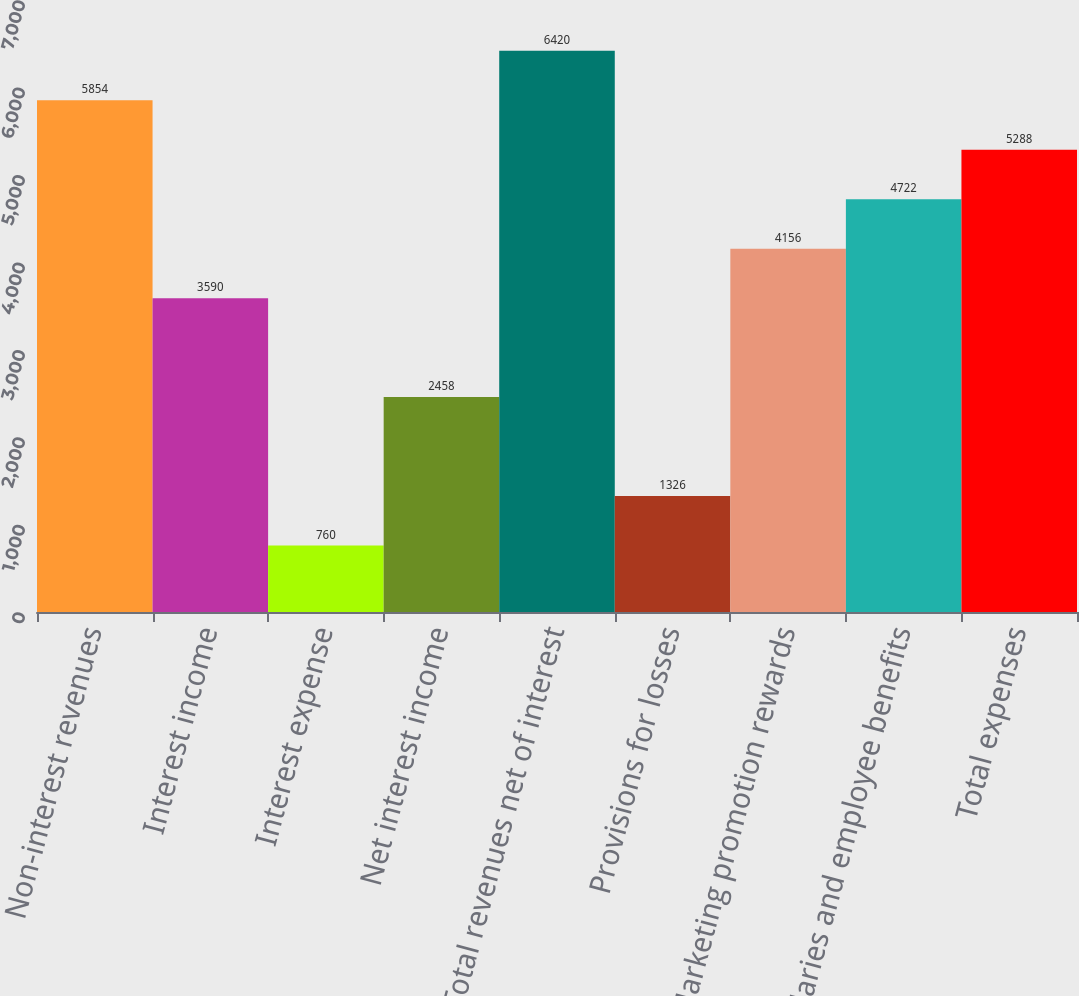Convert chart. <chart><loc_0><loc_0><loc_500><loc_500><bar_chart><fcel>Non-interest revenues<fcel>Interest income<fcel>Interest expense<fcel>Net interest income<fcel>Total revenues net of interest<fcel>Provisions for losses<fcel>Marketing promotion rewards<fcel>Salaries and employee benefits<fcel>Total expenses<nl><fcel>5854<fcel>3590<fcel>760<fcel>2458<fcel>6420<fcel>1326<fcel>4156<fcel>4722<fcel>5288<nl></chart> 